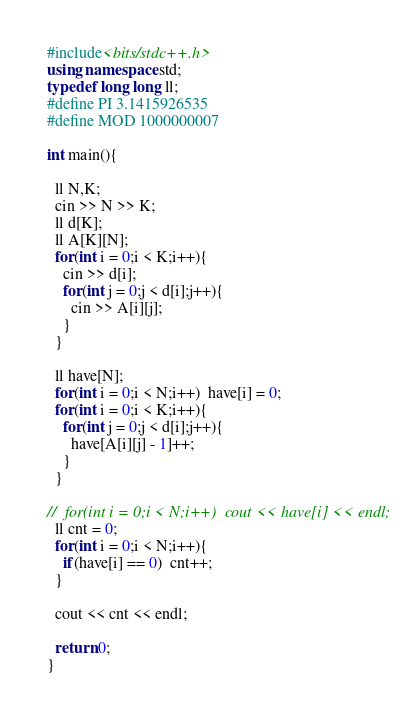<code> <loc_0><loc_0><loc_500><loc_500><_C++_>#include<bits/stdc++.h>
using namespace std;
typedef long long ll;
#define PI 3.1415926535
#define MOD 1000000007
 
int main(){
  
  ll N,K;
  cin >> N >> K;
  ll d[K];
  ll A[K][N];
  for(int i = 0;i < K;i++){
    cin >> d[i];
    for(int j = 0;j < d[i];j++){
      cin >> A[i][j];
    }
  }
  
  ll have[N];
  for(int i = 0;i < N;i++)  have[i] = 0;
  for(int i = 0;i < K;i++){
    for(int j = 0;j < d[i];j++){
      have[A[i][j] - 1]++;
    }
  }
  
//  for(int i = 0;i < N;i++)  cout << have[i] << endl;
  ll cnt = 0;
  for(int i = 0;i < N;i++){
    if(have[i] == 0)  cnt++;
  }
  
  cout << cnt << endl;
  
  return 0;
}</code> 